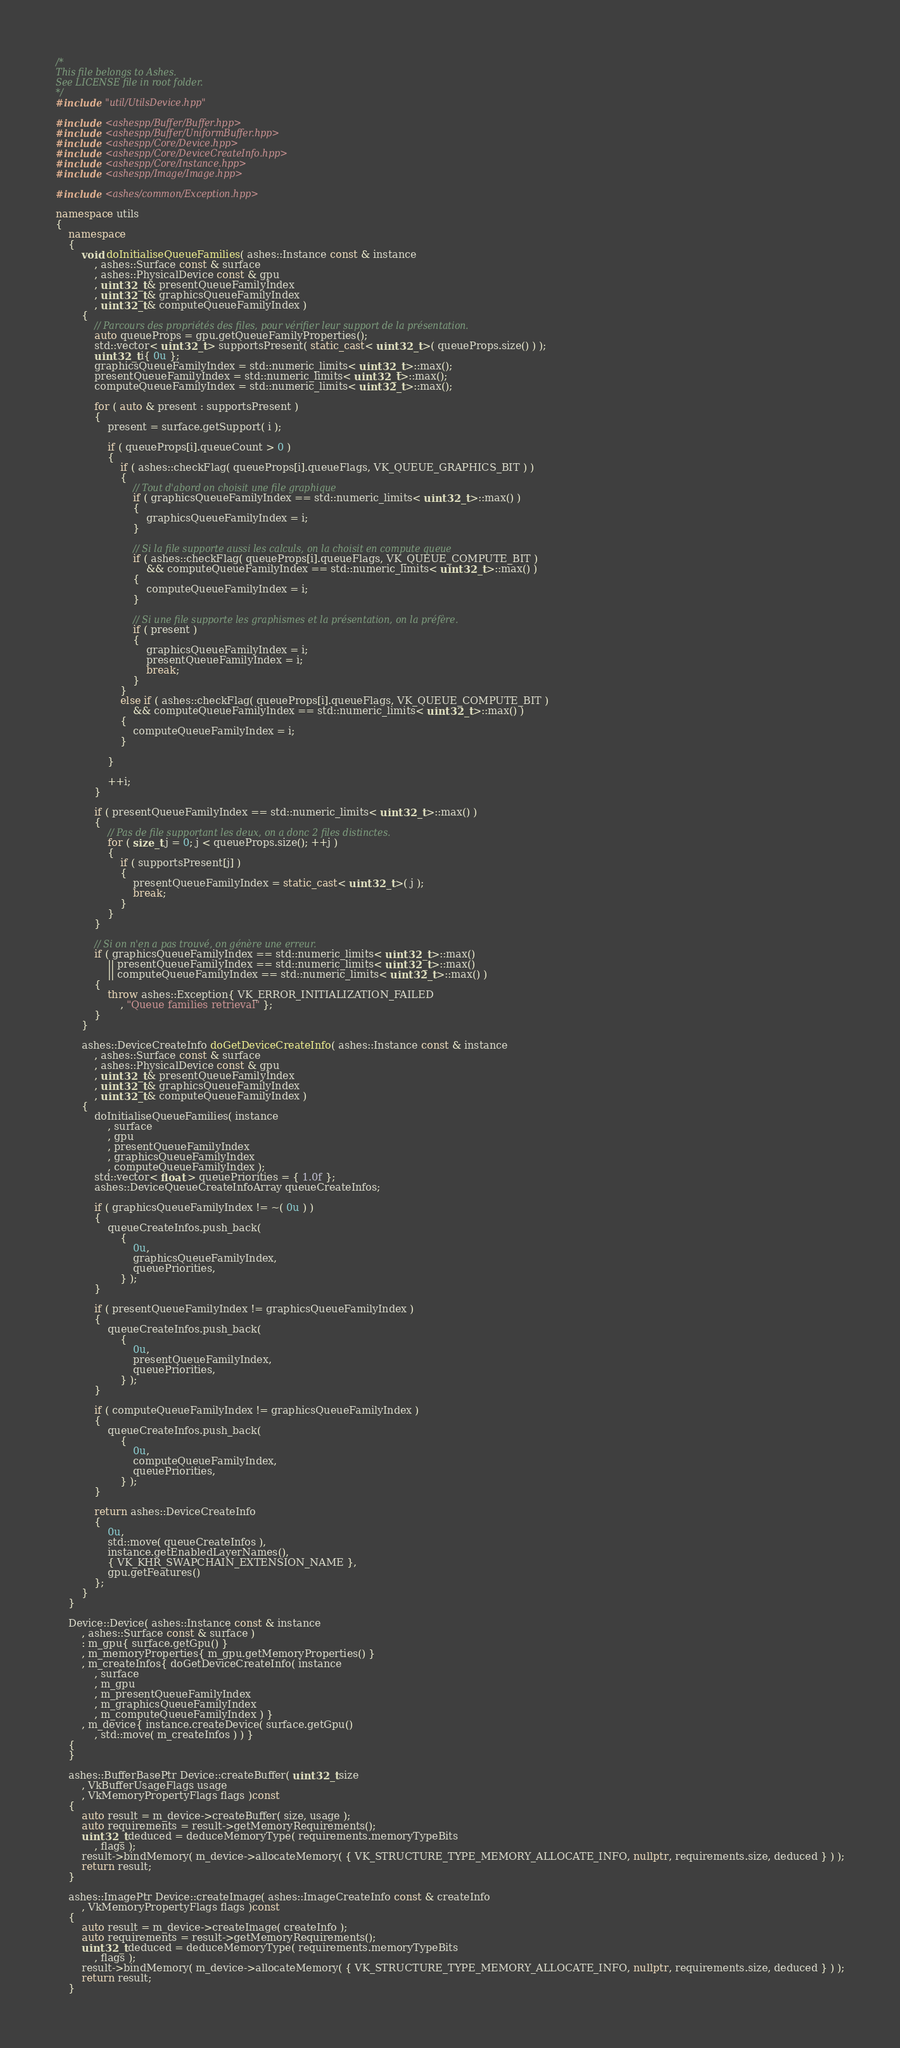Convert code to text. <code><loc_0><loc_0><loc_500><loc_500><_C++_>/*
This file belongs to Ashes.
See LICENSE file in root folder.
*/
#include "util/UtilsDevice.hpp"

#include <ashespp/Buffer/Buffer.hpp>
#include <ashespp/Buffer/UniformBuffer.hpp>
#include <ashespp/Core/Device.hpp>
#include <ashespp/Core/DeviceCreateInfo.hpp>
#include <ashespp/Core/Instance.hpp>
#include <ashespp/Image/Image.hpp>

#include <ashes/common/Exception.hpp>

namespace utils
{
	namespace
	{
		void doInitialiseQueueFamilies( ashes::Instance const & instance
			, ashes::Surface const & surface
			, ashes::PhysicalDevice const & gpu
			, uint32_t & presentQueueFamilyIndex
			, uint32_t & graphicsQueueFamilyIndex
			, uint32_t & computeQueueFamilyIndex )
		{
			// Parcours des propriétés des files, pour vérifier leur support de la présentation.
			auto queueProps = gpu.getQueueFamilyProperties();
			std::vector< uint32_t > supportsPresent( static_cast< uint32_t >( queueProps.size() ) );
			uint32_t i{ 0u };
			graphicsQueueFamilyIndex = std::numeric_limits< uint32_t >::max();
			presentQueueFamilyIndex = std::numeric_limits< uint32_t >::max();
			computeQueueFamilyIndex = std::numeric_limits< uint32_t >::max();

			for ( auto & present : supportsPresent )
			{
				present = surface.getSupport( i );

				if ( queueProps[i].queueCount > 0 )
				{
					if ( ashes::checkFlag( queueProps[i].queueFlags, VK_QUEUE_GRAPHICS_BIT ) )
					{
						// Tout d'abord on choisit une file graphique
						if ( graphicsQueueFamilyIndex == std::numeric_limits< uint32_t >::max() )
						{
							graphicsQueueFamilyIndex = i;
						}

						// Si la file supporte aussi les calculs, on la choisit en compute queue
						if ( ashes::checkFlag( queueProps[i].queueFlags, VK_QUEUE_COMPUTE_BIT )
							&& computeQueueFamilyIndex == std::numeric_limits< uint32_t >::max() )
						{
							computeQueueFamilyIndex = i;
						}

						// Si une file supporte les graphismes et la présentation, on la préfère.
						if ( present )
						{
							graphicsQueueFamilyIndex = i;
							presentQueueFamilyIndex = i;
							break;
						}
					}
					else if ( ashes::checkFlag( queueProps[i].queueFlags, VK_QUEUE_COMPUTE_BIT )
						&& computeQueueFamilyIndex == std::numeric_limits< uint32_t >::max() )
					{
						computeQueueFamilyIndex = i;
					}

				}

				++i;
			}

			if ( presentQueueFamilyIndex == std::numeric_limits< uint32_t >::max() )
			{
				// Pas de file supportant les deux, on a donc 2 files distinctes.
				for ( size_t j = 0; j < queueProps.size(); ++j )
				{
					if ( supportsPresent[j] )
					{
						presentQueueFamilyIndex = static_cast< uint32_t >( j );
						break;
					}
				}
			}

			// Si on n'en a pas trouvé, on génère une erreur.
			if ( graphicsQueueFamilyIndex == std::numeric_limits< uint32_t >::max()
				|| presentQueueFamilyIndex == std::numeric_limits< uint32_t >::max()
				|| computeQueueFamilyIndex == std::numeric_limits< uint32_t >::max() )
			{
				throw ashes::Exception{ VK_ERROR_INITIALIZATION_FAILED
					, "Queue families retrieval" };
			}
		}

		ashes::DeviceCreateInfo doGetDeviceCreateInfo( ashes::Instance const & instance
			, ashes::Surface const & surface
			, ashes::PhysicalDevice const & gpu
			, uint32_t & presentQueueFamilyIndex
			, uint32_t & graphicsQueueFamilyIndex
			, uint32_t & computeQueueFamilyIndex )
		{
			doInitialiseQueueFamilies( instance
				, surface
				, gpu
				, presentQueueFamilyIndex
				, graphicsQueueFamilyIndex
				, computeQueueFamilyIndex );
			std::vector< float > queuePriorities = { 1.0f };
			ashes::DeviceQueueCreateInfoArray queueCreateInfos;

			if ( graphicsQueueFamilyIndex != ~( 0u ) )
			{
				queueCreateInfos.push_back(
					{
						0u,
						graphicsQueueFamilyIndex,
						queuePriorities,
					} );
			}

			if ( presentQueueFamilyIndex != graphicsQueueFamilyIndex )
			{
				queueCreateInfos.push_back(
					{
						0u,
						presentQueueFamilyIndex,
						queuePriorities,
					} );
			}

			if ( computeQueueFamilyIndex != graphicsQueueFamilyIndex )
			{
				queueCreateInfos.push_back(
					{
						0u,
						computeQueueFamilyIndex,
						queuePriorities,
					} );
			}

			return ashes::DeviceCreateInfo
			{
				0u,
				std::move( queueCreateInfos ),
				instance.getEnabledLayerNames(),
				{ VK_KHR_SWAPCHAIN_EXTENSION_NAME },
				gpu.getFeatures()
			};
		}
	}

	Device::Device( ashes::Instance const & instance
		, ashes::Surface const & surface )
		: m_gpu{ surface.getGpu() }
		, m_memoryProperties{ m_gpu.getMemoryProperties() }
		, m_createInfos{ doGetDeviceCreateInfo( instance
			, surface
			, m_gpu
			, m_presentQueueFamilyIndex
			, m_graphicsQueueFamilyIndex
			, m_computeQueueFamilyIndex ) }
		, m_device{ instance.createDevice( surface.getGpu()
			, std::move( m_createInfos ) ) }
	{
	}

	ashes::BufferBasePtr Device::createBuffer( uint32_t size
		, VkBufferUsageFlags usage
		, VkMemoryPropertyFlags flags )const
	{
		auto result = m_device->createBuffer( size, usage );
		auto requirements = result->getMemoryRequirements();
		uint32_t deduced = deduceMemoryType( requirements.memoryTypeBits
			, flags );
		result->bindMemory( m_device->allocateMemory( { VK_STRUCTURE_TYPE_MEMORY_ALLOCATE_INFO, nullptr, requirements.size, deduced } ) );
		return result;
	}

	ashes::ImagePtr Device::createImage( ashes::ImageCreateInfo const & createInfo
		, VkMemoryPropertyFlags flags )const
	{
		auto result = m_device->createImage( createInfo );
		auto requirements = result->getMemoryRequirements();
		uint32_t deduced = deduceMemoryType( requirements.memoryTypeBits
			, flags );
		result->bindMemory( m_device->allocateMemory( { VK_STRUCTURE_TYPE_MEMORY_ALLOCATE_INFO, nullptr, requirements.size, deduced } ) );
		return result;
	}
</code> 